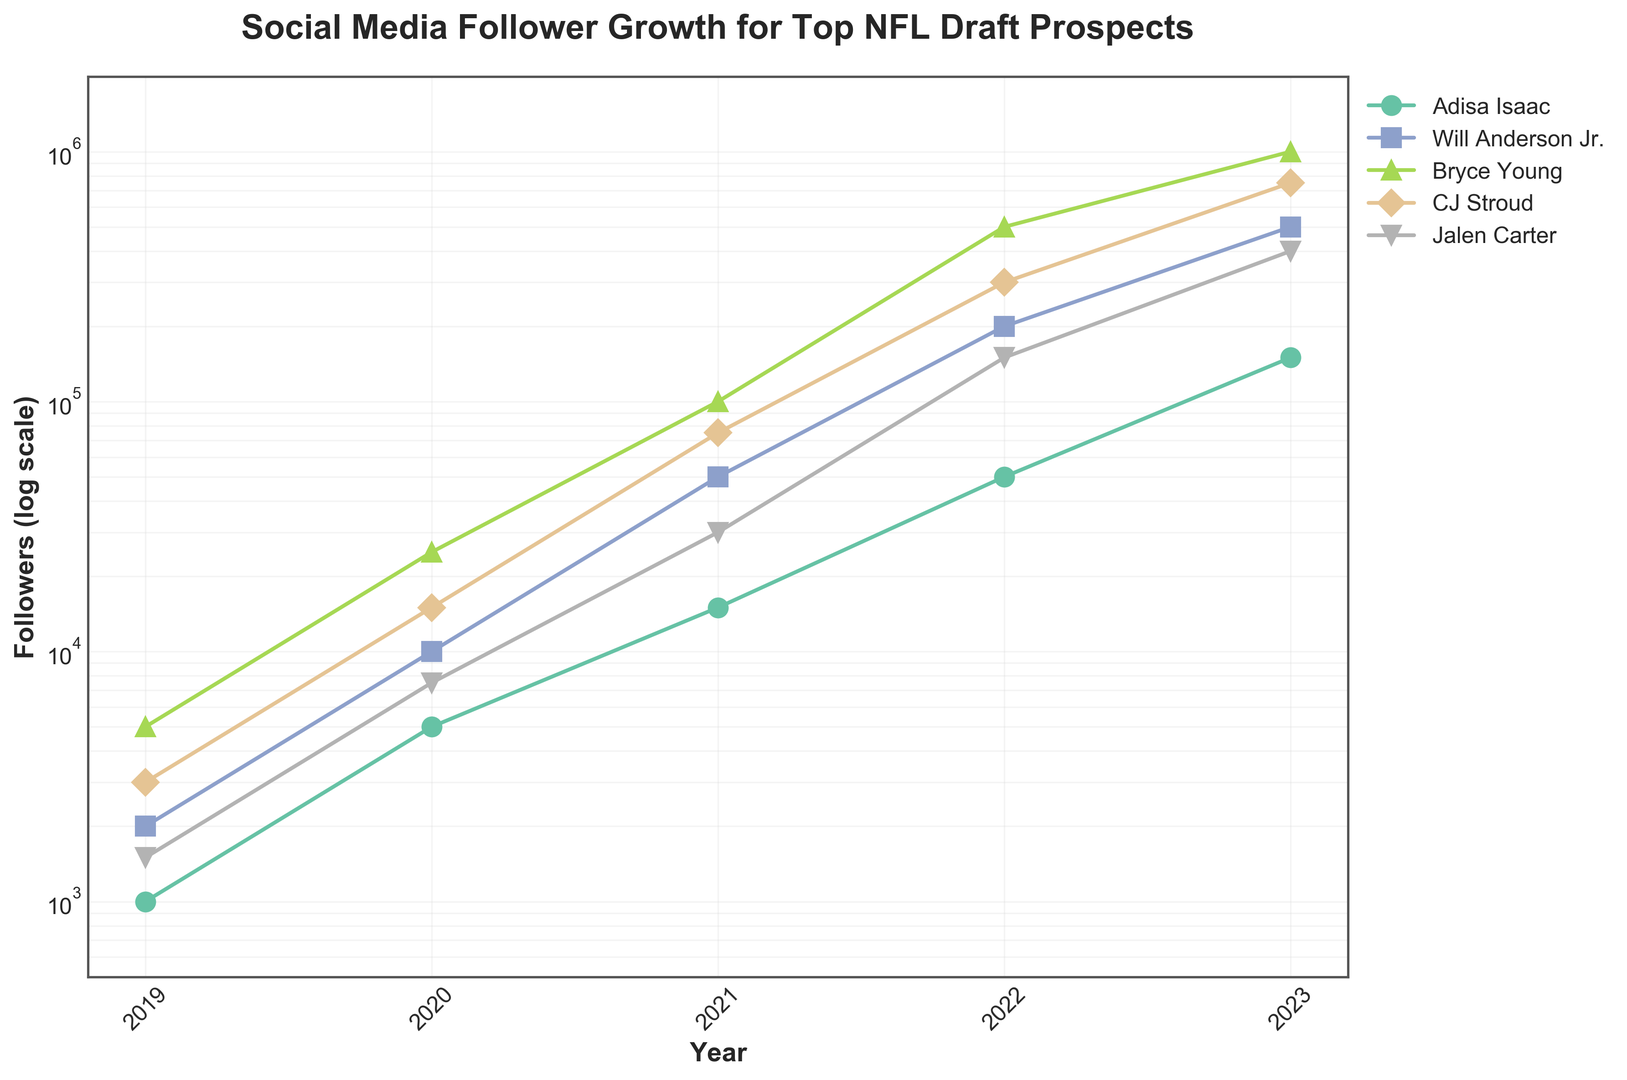How does Adisa Isaac's follower growth compare to Will Anderson Jr.'s over the years? To compare the follower growth of Adisa Isaac and Will Anderson Jr., look at their respective follower counts for each year. Adisa Isaac starts at 1,000 followers in 2019 and grows to 150,000 by 2023. Will Anderson Jr. starts at 2,000 followers in 2019 and grows to 500,000 by 2023. Will Anderson Jr.'s follower count is consistently higher each year.
Answer: Will Anderson Jr.'s growth is greater How many followers in total did Adisa Isaac gain between the years 2019 and 2023? To find the total number of followers gained, subtract the initial number of followers in 2019 from the number of followers in 2023 for Adisa Isaac: 150,000 (2023) - 1,000 (2019) = 149,000.
Answer: 149,000 Between which consecutive years did Adisa Isaac see the largest increase in followers? Compare the yearly increases for Adisa Isaac: 2020-2019 (4,000), 2021-2020 (10,000), 2022-2021 (35,000), and 2023-2022 (100,000). The largest increase is from 2022 to 2023.
Answer: 2022-2023 Whose follower count grew the most rapidly in their final year? To determine the rapid growth, compare the follower increase for each player from 2022 to 2023. Adisa Isaac (100,000), Will Anderson Jr. (300,000), Bryce Young (500,000), CJ Stroud (450,000), and Jalen Carter (250,000). Bryce Young's follower count grew the most rapidly in the final year.
Answer: Bryce Young Based on the graph, who had the highest follower count at the end of 2023? Look at the endpoint of each player's curve in 2023. Bryce Young has the highest follower count at 1,000,000.
Answer: Bryce Young What was the difference in follower count between Bryce Young and Adisa Isaac in 2022? Subtract Adisa Isaac's followers in 2022 (50,000) from Bryce Young's followers in 2022 (500,000): 500,000 - 50,000 = 450,000.
Answer: 450,000 What trend can you observe in Adisa Isaac's follower growth compared to CJ Stroud's from 2019 to 2023? Both Adisa Isaac and CJ Stroud show an upward trend in follower growth. However, CJ Stroud consistently has a higher starting follower count each year and sees overall higher increases, especially in the latter years.
Answer: CJ Stroud's growth is higher By what factor did Jalen Carter's followers increase from 2019 to 2023? Divide Jalen Carter's followers in 2023 by his followers in 2019: 400,000 / 1,500. This results in approximately 266.67.
Answer: 266.67 What is the visual difference between the curves of Adisa Isaac and Bryce Young regarding steepness? Bryce Young's curve is steeper, indicating more rapid follower growth compared to Adisa Isaac's curve which is more gradual.
Answer: Bryce Young is steeper Comparing all players, who experienced the smallest increase in followers from 2020 to 2021? Evaluate the growth for each player from 2020 to 2021: Adisa Isaac (10,000), Will Anderson Jr. (40,000), Bryce Young (75,000), CJ Stroud (60,000), Jalen Carter (22,500). Adisa Isaac experienced the smallest increase.
Answer: Adisa Isaac 